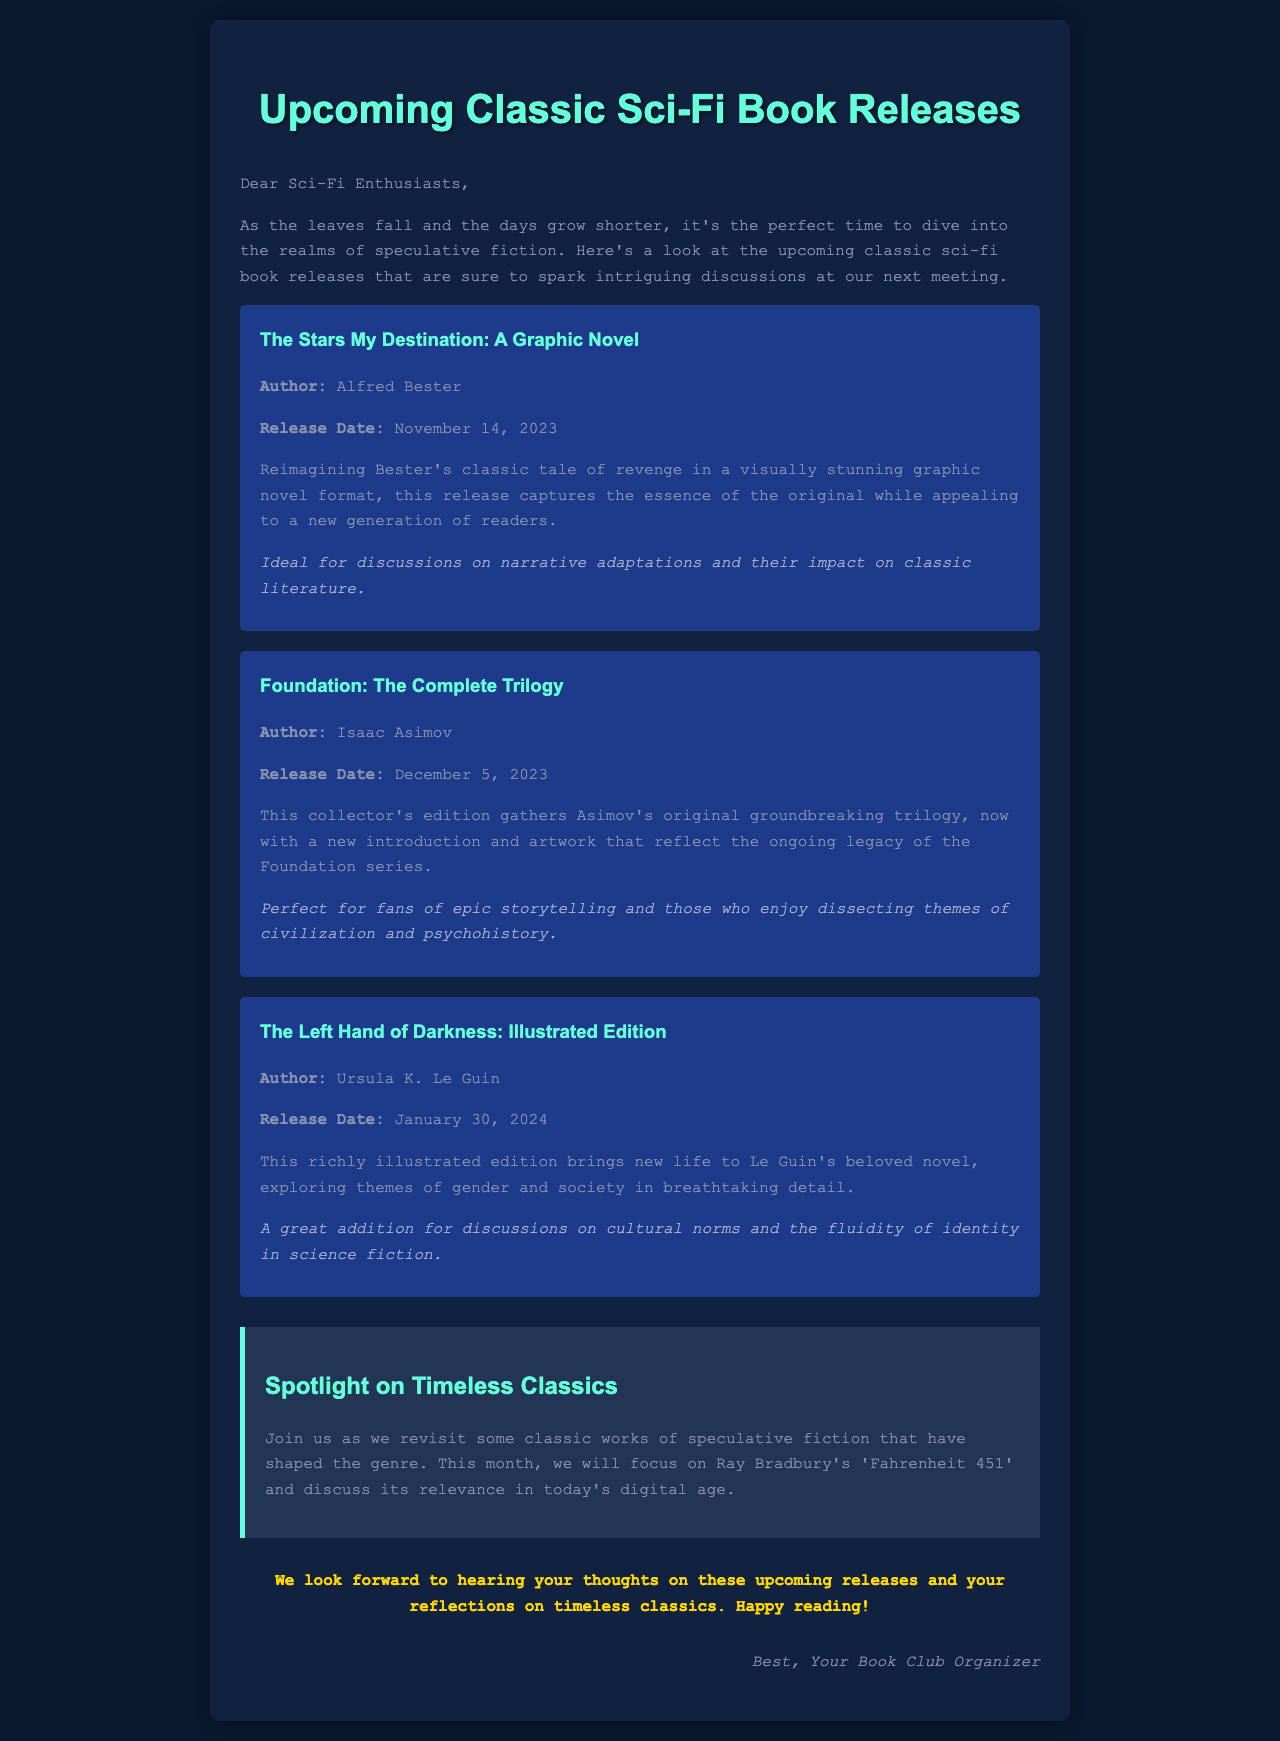What is the title of the upcoming graphic novel? The title of the upcoming graphic novel is specified in the document.
Answer: The Stars My Destination: A Graphic Novel Who is the author of "Foundation: The Complete Trilogy"? The author of "Foundation: The Complete Trilogy" is mentioned in the document.
Answer: Isaac Asimov When is the release date for "The Left Hand of Darkness: Illustrated Edition"? The release date for "The Left Hand of Darkness: Illustrated Edition" is provided in the document.
Answer: January 30, 2024 What themes are explored in the illustrated edition of "The Left Hand of Darkness"? The document notes that the illustrated edition explores specific themes.
Answer: Gender and society What additional feature is highlighted in the newsletter? The newsletter includes a feature that focuses on a specific classic work.
Answer: Spotlight on Timeless Classics Which classic author is discussed in the special feature? The special feature includes a discussion about a certain classic author.
Answer: Ray Bradbury 